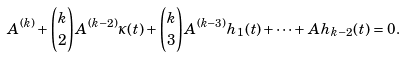Convert formula to latex. <formula><loc_0><loc_0><loc_500><loc_500>A ^ { ( k ) } + { k \choose 2 } A ^ { ( k - 2 ) } \kappa ( t ) + { k \choose 3 } A ^ { ( k - 3 ) } h _ { 1 } ( t ) + \dots + A h _ { k - 2 } ( t ) = 0 .</formula> 